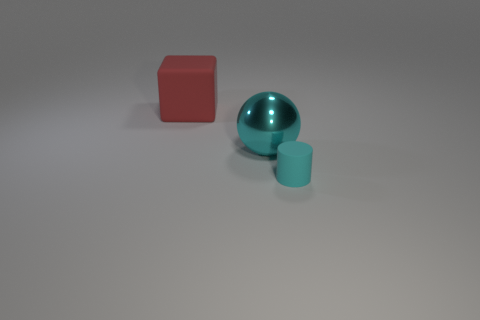Add 1 large yellow blocks. How many objects exist? 4 Subtract all spheres. How many objects are left? 2 Subtract 1 cubes. How many cubes are left? 0 Subtract all green balls. Subtract all gray blocks. How many balls are left? 1 Subtract all blue blocks. How many red cylinders are left? 0 Subtract all tiny purple spheres. Subtract all cyan metal balls. How many objects are left? 2 Add 1 big red rubber blocks. How many big red rubber blocks are left? 2 Add 3 cyan matte spheres. How many cyan matte spheres exist? 3 Subtract 0 green spheres. How many objects are left? 3 